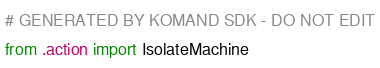Convert code to text. <code><loc_0><loc_0><loc_500><loc_500><_Python_># GENERATED BY KOMAND SDK - DO NOT EDIT
from .action import IsolateMachine
</code> 